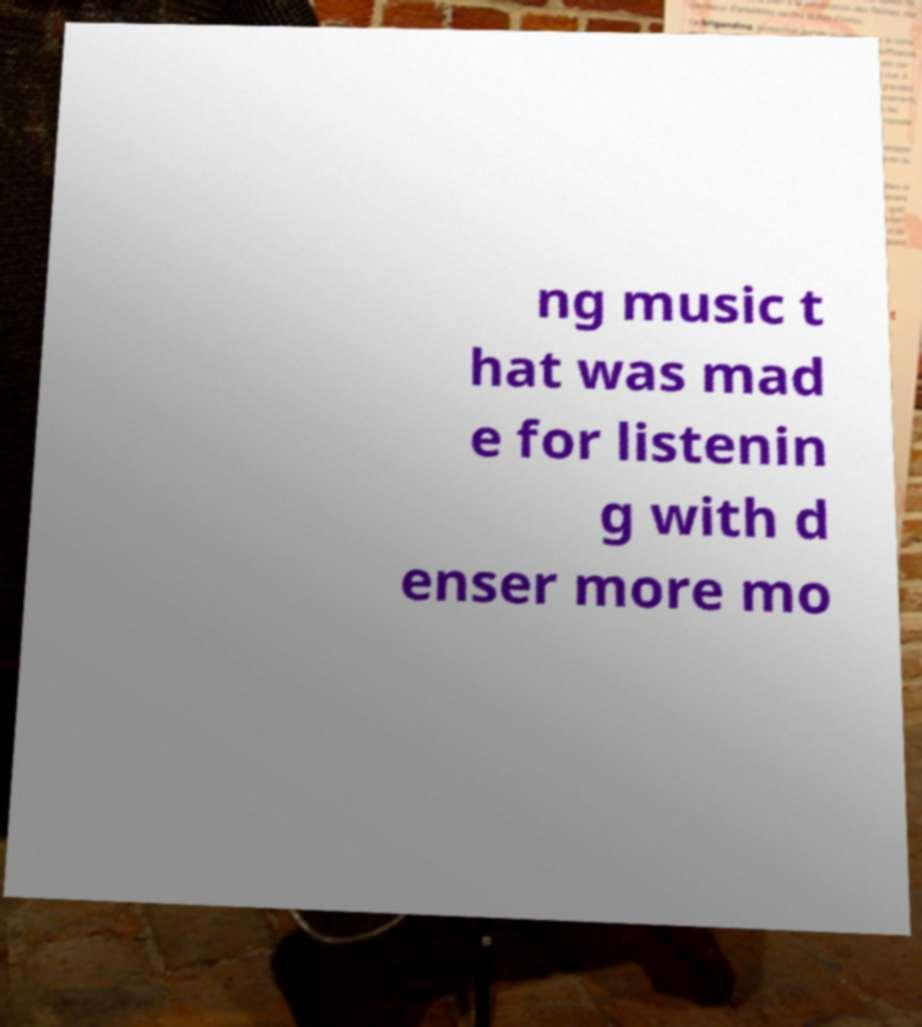Could you extract and type out the text from this image? ng music t hat was mad e for listenin g with d enser more mo 